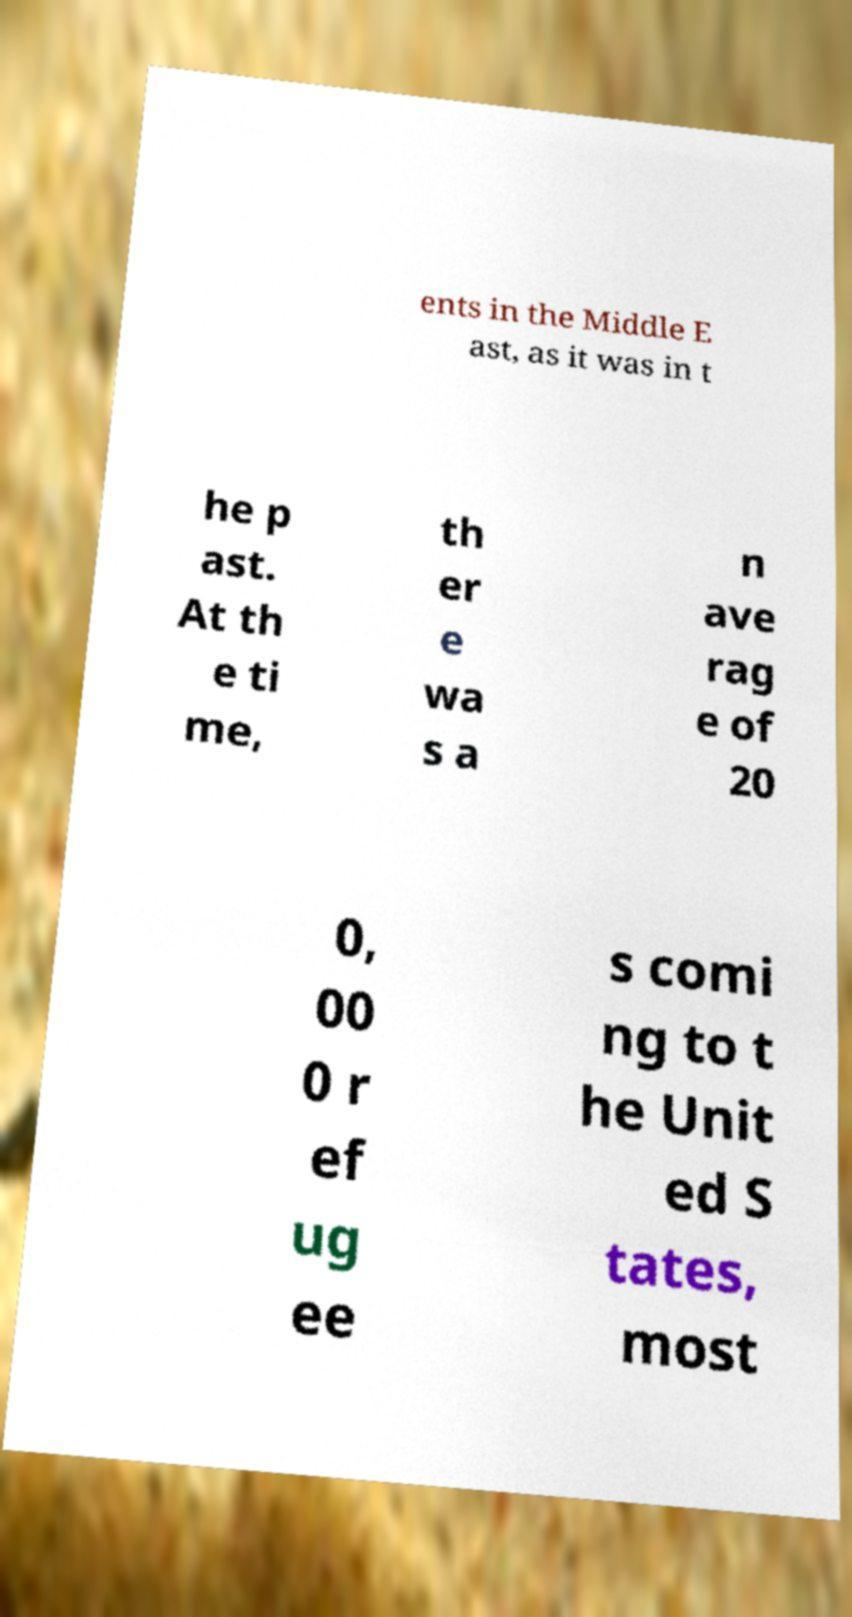Could you extract and type out the text from this image? ents in the Middle E ast, as it was in t he p ast. At th e ti me, th er e wa s a n ave rag e of 20 0, 00 0 r ef ug ee s comi ng to t he Unit ed S tates, most 